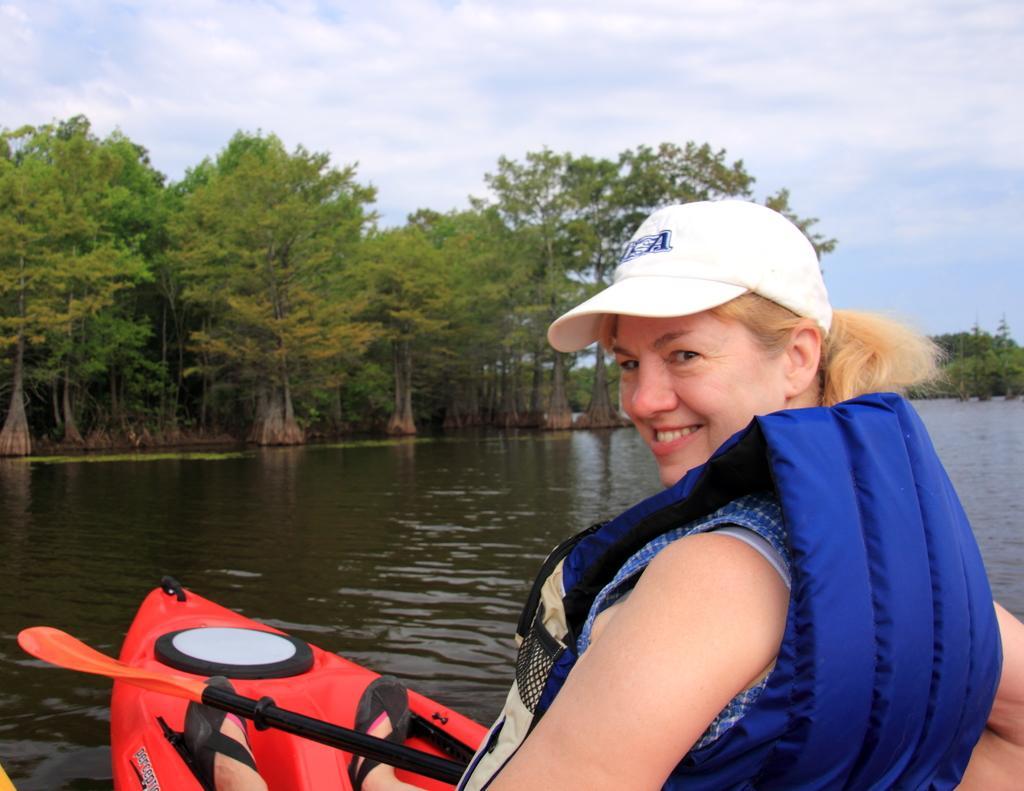Can you describe this image briefly? In this picture I can see a woman in a boat, she is wearing a life jacket. In the middle there is water, in the background I can see trees. At the top there is the sky. 